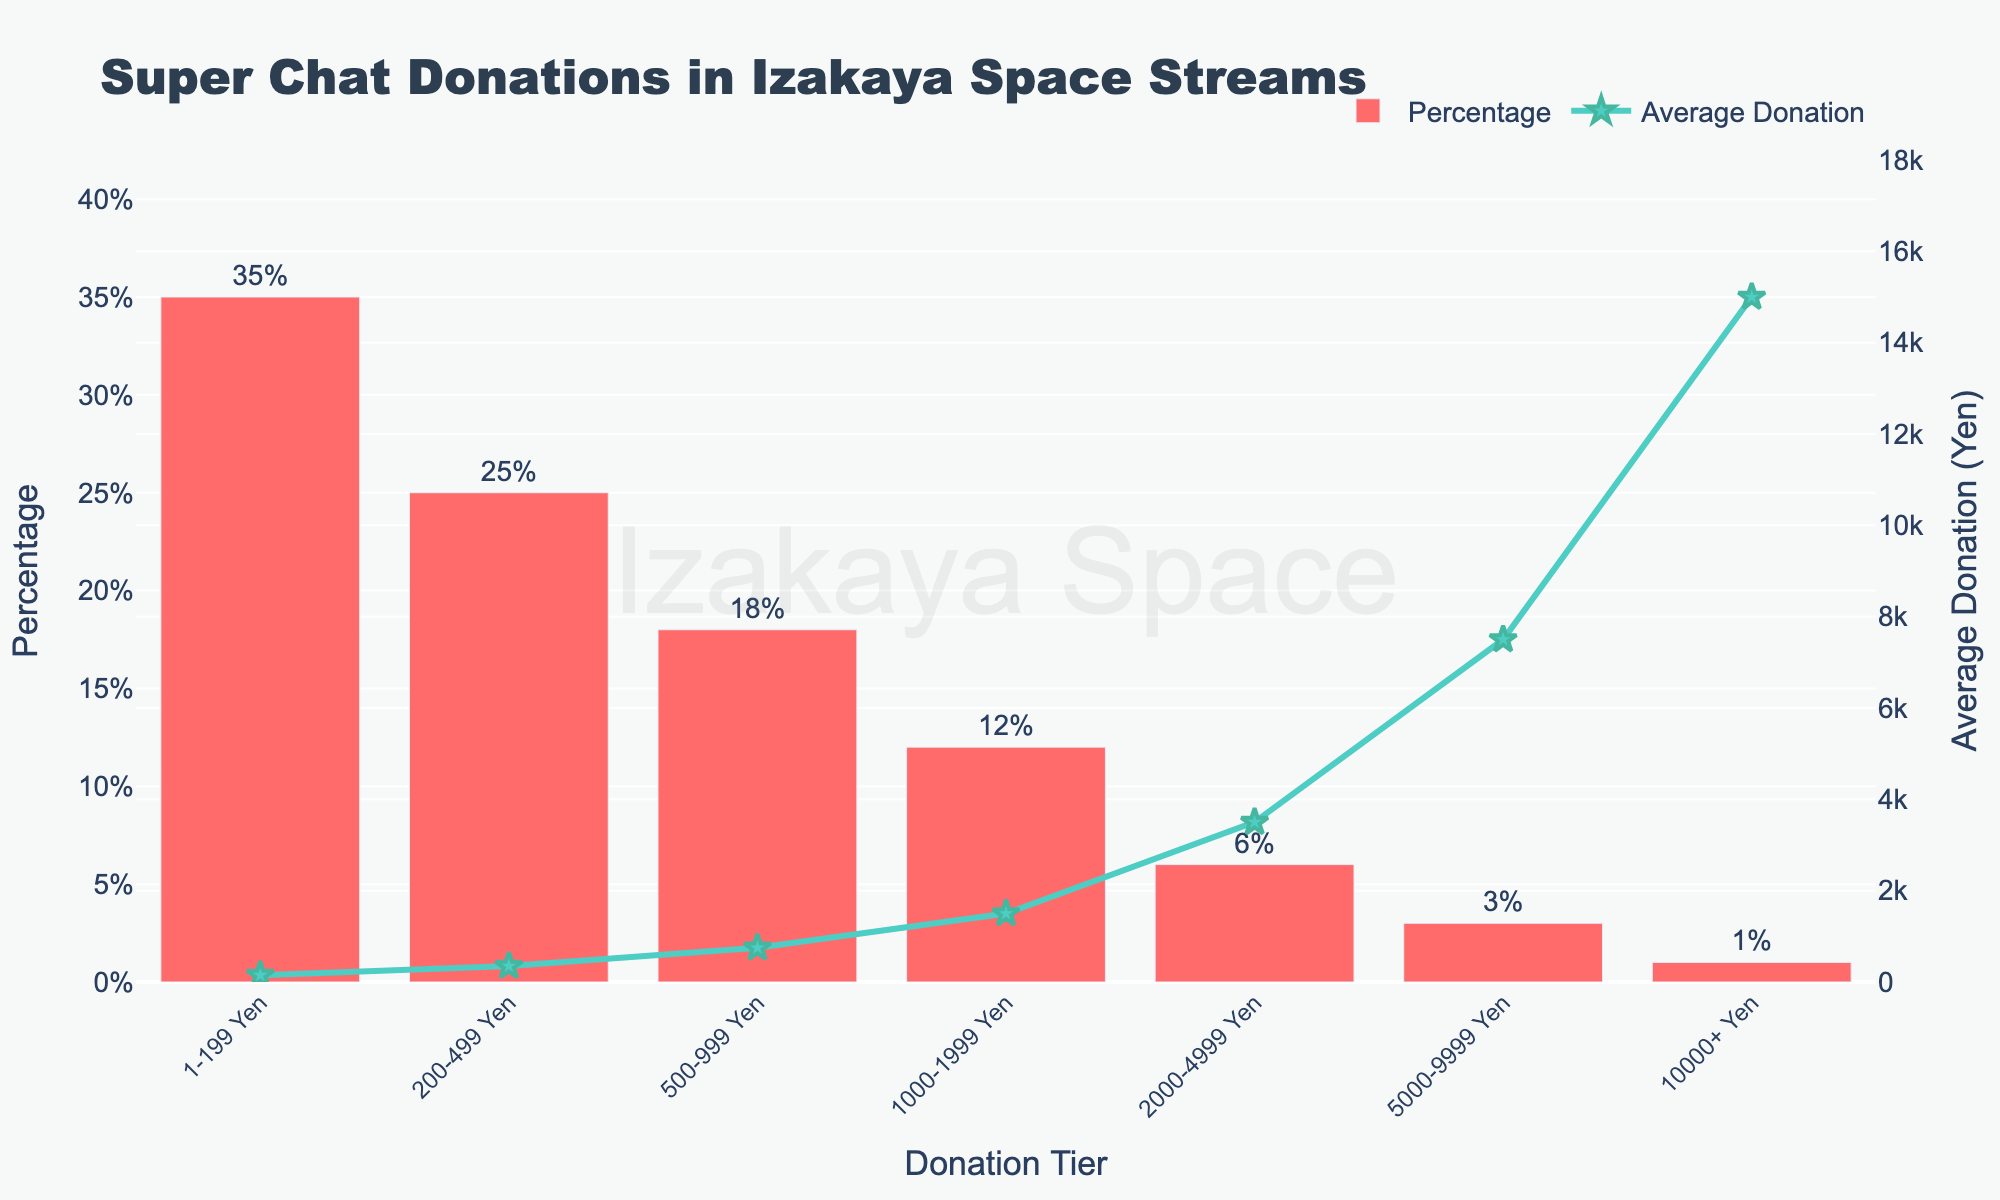What's the highest average donation tier? The bar chart includes tiers with both percentage and average donation values. From the values shown, identify the tier with the highest 'Average Donation (Yen)' value. The tier '10000+ Yen' has the highest average donation value of ¥15000.
Answer: 10000+ Yen Which tier has the highest percentage of donations? Locate the bar with the highest height representing the 'Percentage'. The tallest bar corresponds to the '1-199 Yen' tier with a percentage of 35%.
Answer: 1-199 Yen What is the average donation for the tier with the lowest percentage? Find the tier with the smallest bar height for 'Percentage'. The '10000+ Yen' tier has the lowest percentage (1%), and its average donation is ¥15000.
Answer: ¥15000 Compare the average donation between '500-999 Yen' and '1000-1999 Yen' tiers. Which one is higher and by how much? Lookup the average donation for both '500-999 Yen' (¥750) and '1000-1999 Yen' (¥1500). Calculate the difference: ¥1500 - ¥750 = ¥750.
Answer: 1000-1999 Yen, ¥750 Which tier has a higher percentage: '200-499 Yen' or '500-999 Yen'? Compare the percentage values of both tiers. '200-499 Yen' (25%) vs. '500-999 Yen' (18%) shows that '200-499 Yen' has a higher percentage.
Answer: 200-499 Yen What's the combined percentage of donations for all tiers above '1000 Yen'? Add the percentages of tiers above '1000 Yen'. '1000-1999 Yen' (12%) + '2000-4999 Yen' (6%) + '5000-9999 Yen' (3%) + '10000+ Yen' (1%) = 22%.
Answer: 22% Between which two consecutive tiers is the drop in percentage the largest? Examine the percentage drop between consecutive tiers: 
'1-199 Yen' to '200-499 Yen' (35% - 25% = 10%), 
'200-499 Yen' to '500-999 Yen' (25% - 18% = 7%), 
'500-999 Yen' to '1000-1999 Yen' (18% - 12% = 6%), 
'1000-1999 Yen' to '2000-4999 Yen' (12% - 6% = 6%), 
'2000-4999 Yen' to '5000-9999 Yen' (6% - 3% = 3%), 
'5000-9999 Yen' to '10000+ Yen' (3% - 1% = 2%). The largest drop is between '1-199 Yen' and '200-499 Yen'.
Answer: 1-199 Yen and 200-499 Yen Which tier contributes more to the overall donations percentage: '5000-9999 Yen' or '2000-4999 Yen'? Compare the percentage values of both tiers. '5000-9999 Yen' (3%) vs. '2000-4999 Yen' (6%) shows that '2000-4999 Yen' has a higher percentage.
Answer: 2000-4999 Yen What is the midpoint (average) of the percentages for the tiers '500-999 Yen' and '200-499 Yen'? Calculate the midpoint by averaging the percentages for '500-999 Yen' (18%) and '200-499 Yen' (25%). (18% + 25%) / 2 = 21.5%.
Answer: 21.5% 